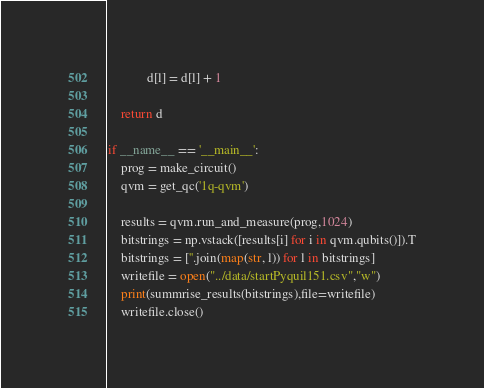Convert code to text. <code><loc_0><loc_0><loc_500><loc_500><_Python_>            d[l] = d[l] + 1

    return d

if __name__ == '__main__':
    prog = make_circuit()
    qvm = get_qc('1q-qvm')

    results = qvm.run_and_measure(prog,1024)
    bitstrings = np.vstack([results[i] for i in qvm.qubits()]).T
    bitstrings = [''.join(map(str, l)) for l in bitstrings]
    writefile = open("../data/startPyquil151.csv","w")
    print(summrise_results(bitstrings),file=writefile)
    writefile.close()

</code> 